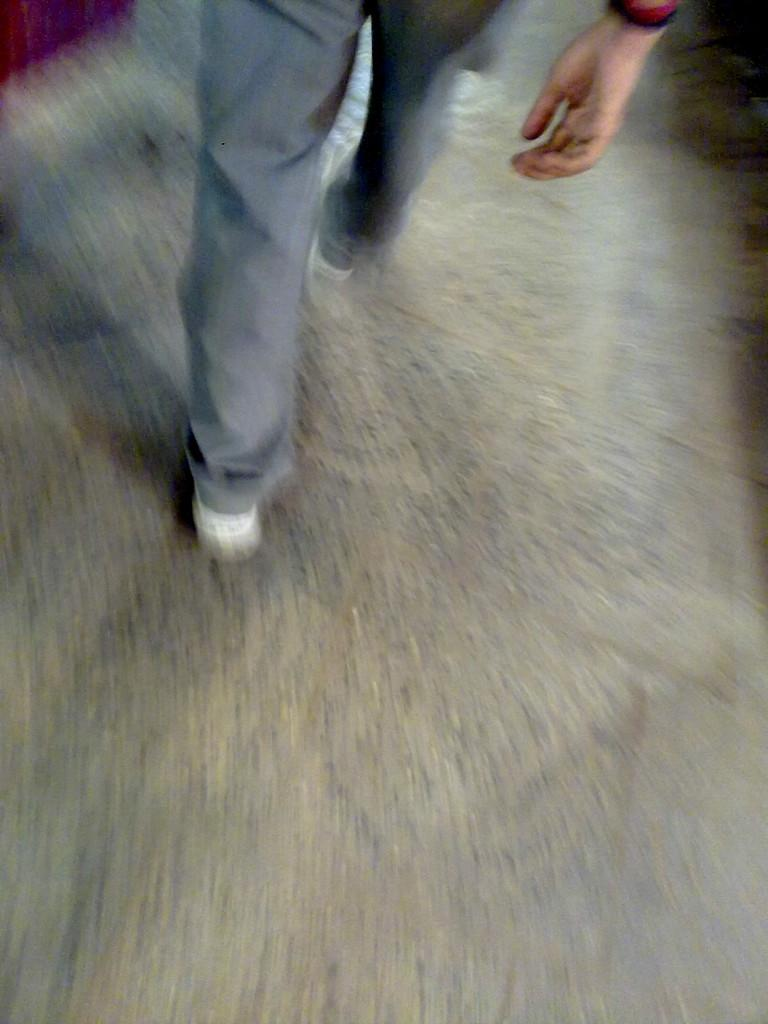Who is present in the image? There is a man in the image. What is the man doing in the image? The man is walking on the floor. What type of snake can be seen slithering on the man's leg in the image? There is no snake present in the image; the man is simply walking on the floor. 